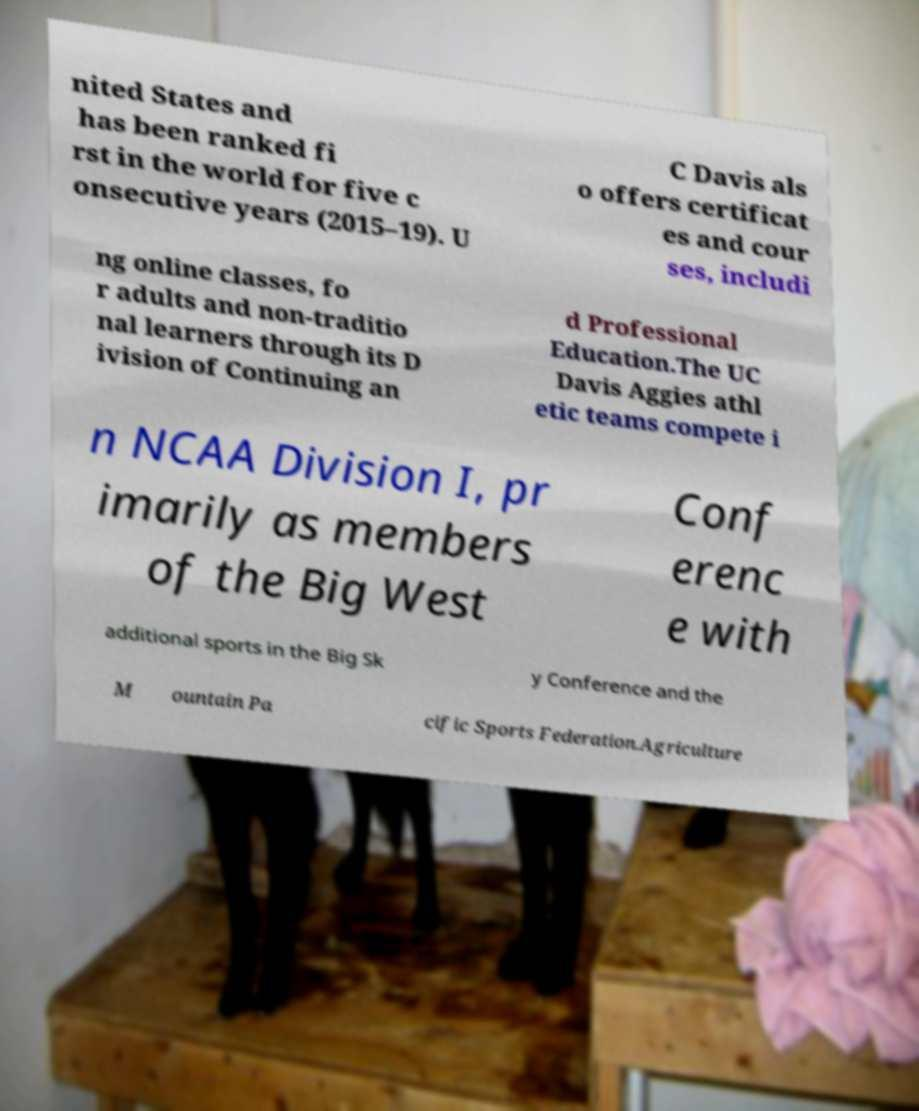Can you read and provide the text displayed in the image?This photo seems to have some interesting text. Can you extract and type it out for me? nited States and has been ranked fi rst in the world for five c onsecutive years (2015–19). U C Davis als o offers certificat es and cour ses, includi ng online classes, fo r adults and non-traditio nal learners through its D ivision of Continuing an d Professional Education.The UC Davis Aggies athl etic teams compete i n NCAA Division I, pr imarily as members of the Big West Conf erenc e with additional sports in the Big Sk y Conference and the M ountain Pa cific Sports Federation.Agriculture 